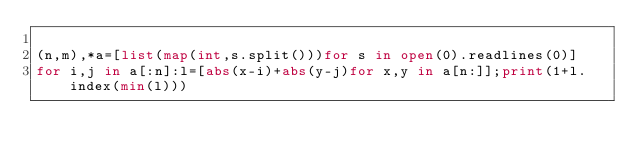Convert code to text. <code><loc_0><loc_0><loc_500><loc_500><_Python_>
(n,m),*a=[list(map(int,s.split()))for s in open(0).readlines(0)]
for i,j in a[:n]:l=[abs(x-i)+abs(y-j)for x,y in a[n:]];print(1+l.index(min(l)))</code> 